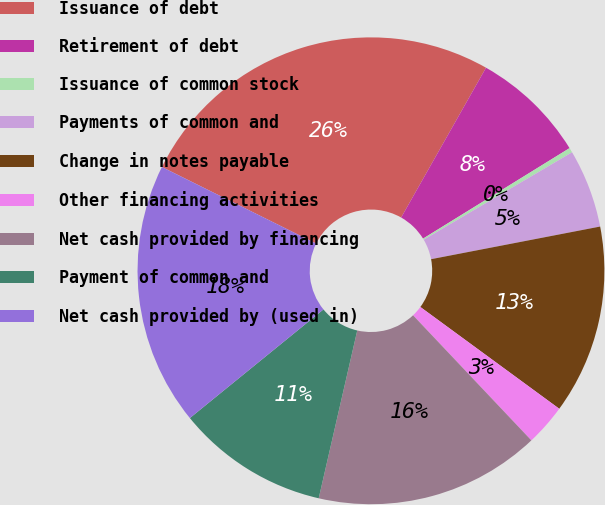<chart> <loc_0><loc_0><loc_500><loc_500><pie_chart><fcel>Issuance of debt<fcel>Retirement of debt<fcel>Issuance of common stock<fcel>Payments of common and<fcel>Change in notes payable<fcel>Other financing activities<fcel>Net cash provided by financing<fcel>Payment of common and<fcel>Net cash provided by (used in)<nl><fcel>25.87%<fcel>7.99%<fcel>0.33%<fcel>5.44%<fcel>13.1%<fcel>2.88%<fcel>15.65%<fcel>10.54%<fcel>18.2%<nl></chart> 